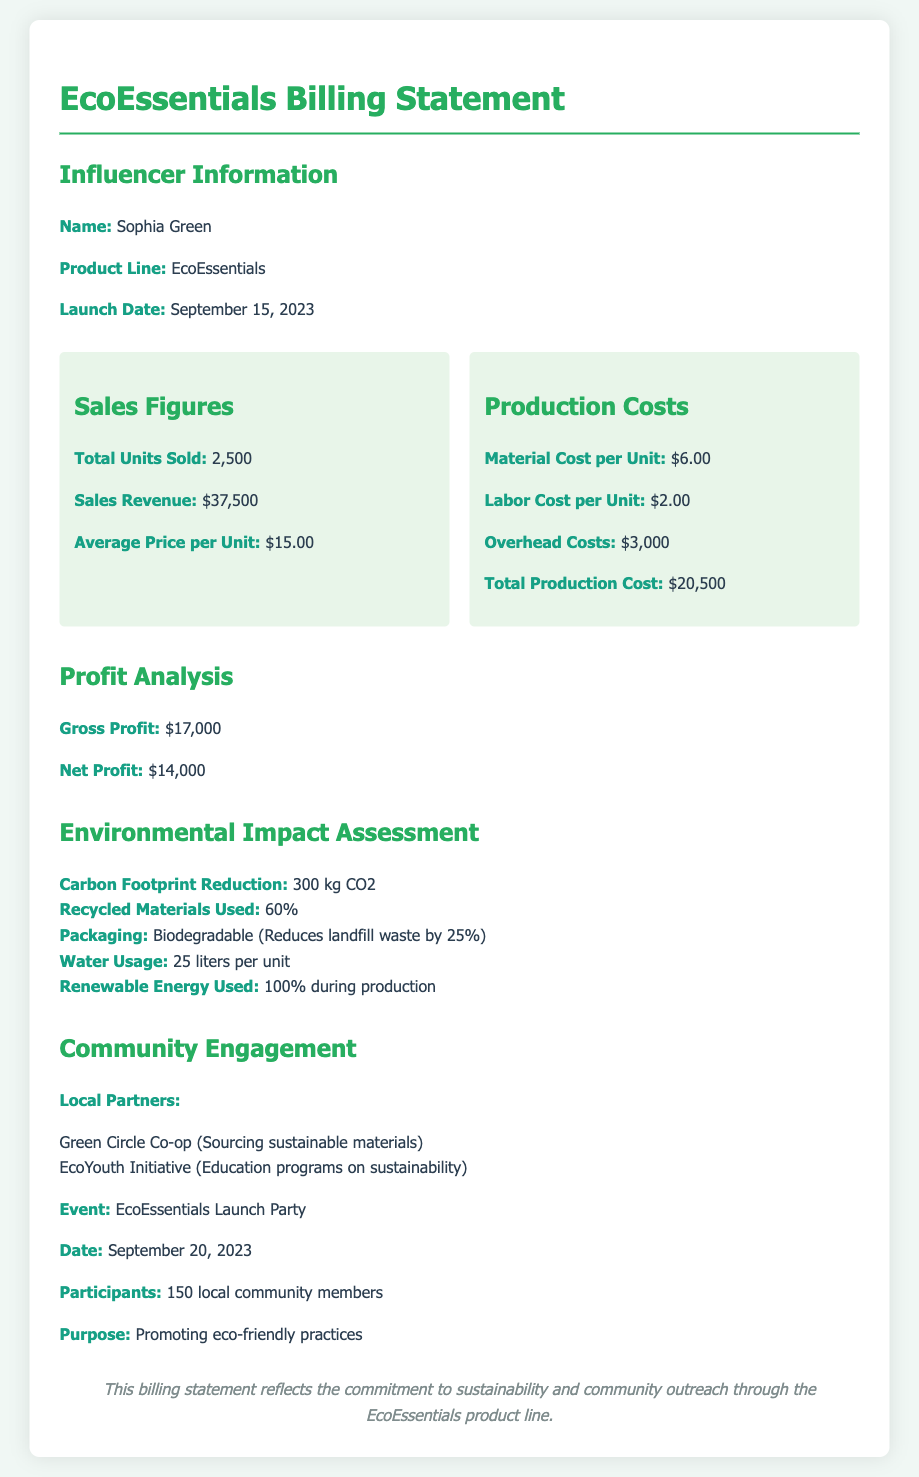what is the name of the influencer? The influencer's name is listed prominently in the document.
Answer: Sophia Green when was the EcoEssentials product line launched? The launch date of the product line is specified in the document.
Answer: September 15, 2023 how many total units were sold? The document provides a specific number for total units sold.
Answer: 2,500 what is the total production cost? The total production cost is outlined within the production costs section of the document.
Answer: $20,500 what was the net profit from the sales? The document states the net profit clearly under the profit analysis section.
Answer: $14,000 which materials usage reduction is indicated? The environmental impact assessment includes specific information on materials usage.
Answer: 60% what percentage of the packaging is biodegradable? The document specifies the type of packaging used for the product.
Answer: Biodegradable who were the local partners listed in the document? The document mentions specific partners in the community engagement section.
Answer: Green Circle Co-op, EcoYouth Initiative how many community members participated in the launch event? The number of participants at the launch event is mentioned in the document.
Answer: 150 what event is associated with the EcoEssentials product line? The document outlines a specific event related to the product line.
Answer: EcoEssentials Launch Party 